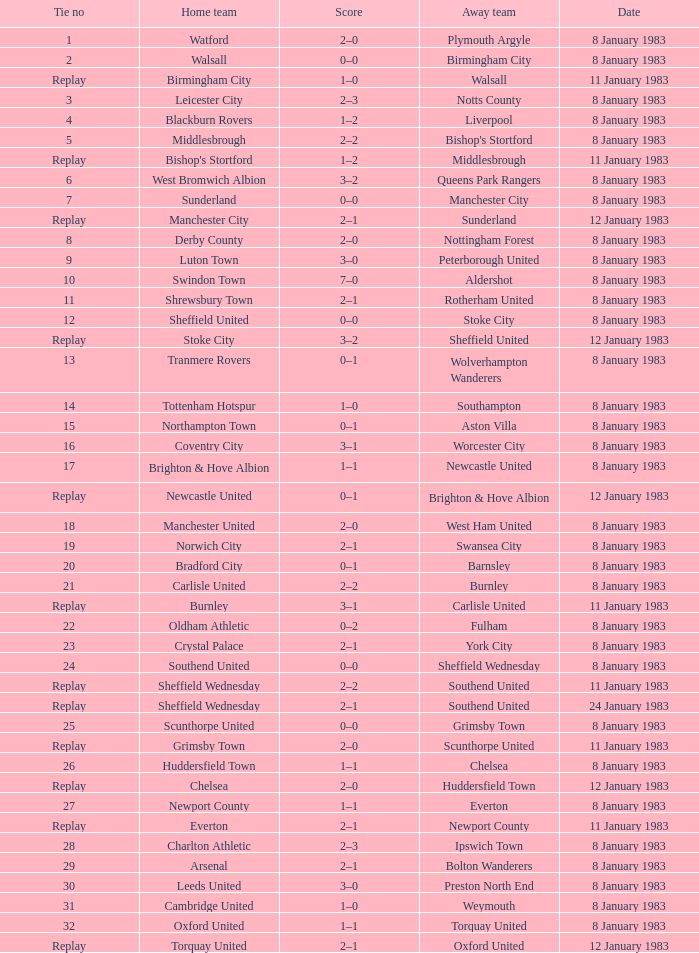In the tie where Southampton was the away team, who was the home team? Tottenham Hotspur. 